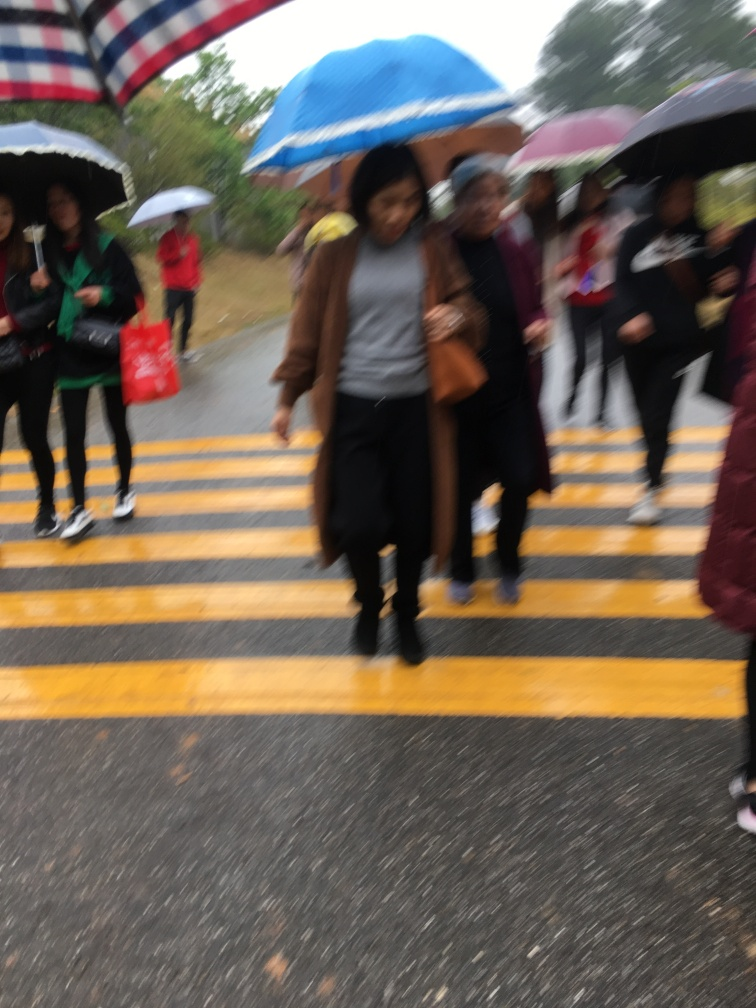Could you comment on the composition and quality of this photo? Sure, the composition centers on the action of pedestrians crossing the street, which is a dynamic and relatable moment. However, the quality of the photo is compromised by its blurriness, which obscures the details and expressions of the people. It’s likely the result of motion blur due to camera shake or a slow shutter speed, given that the subjects were in motion. 